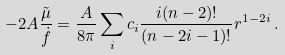<formula> <loc_0><loc_0><loc_500><loc_500>- 2 A \frac { \tilde { \mu } } { \dot { f } } = \frac { A } { 8 \pi } \sum _ { i } c _ { i } \frac { i ( n - 2 ) ! } { ( n - 2 i - 1 ) ! } r ^ { 1 - 2 i } \, .</formula> 